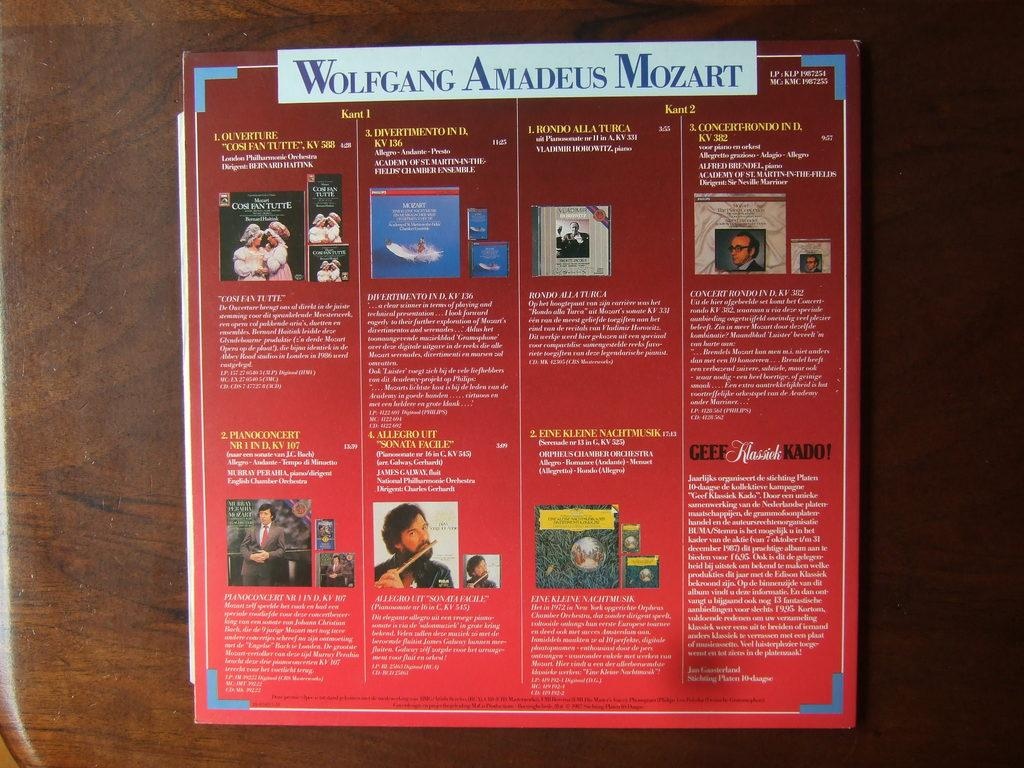<image>
Summarize the visual content of the image. The back side of a Wolfgang Amadeus Mozart album cover. 